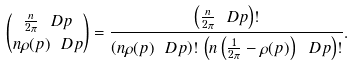Convert formula to latex. <formula><loc_0><loc_0><loc_500><loc_500>\binom { \frac { n } { 2 \pi } \ D p } { n \rho ( p ) \ D p } = \frac { \left ( \frac { n } { 2 \pi } \ D p \right ) ! } { \left ( n \rho ( p ) \ D p \right ) ! \, \left ( n \left ( \frac { 1 } { 2 \pi } - \rho ( p ) \right ) \ D p \right ) ! } .</formula> 